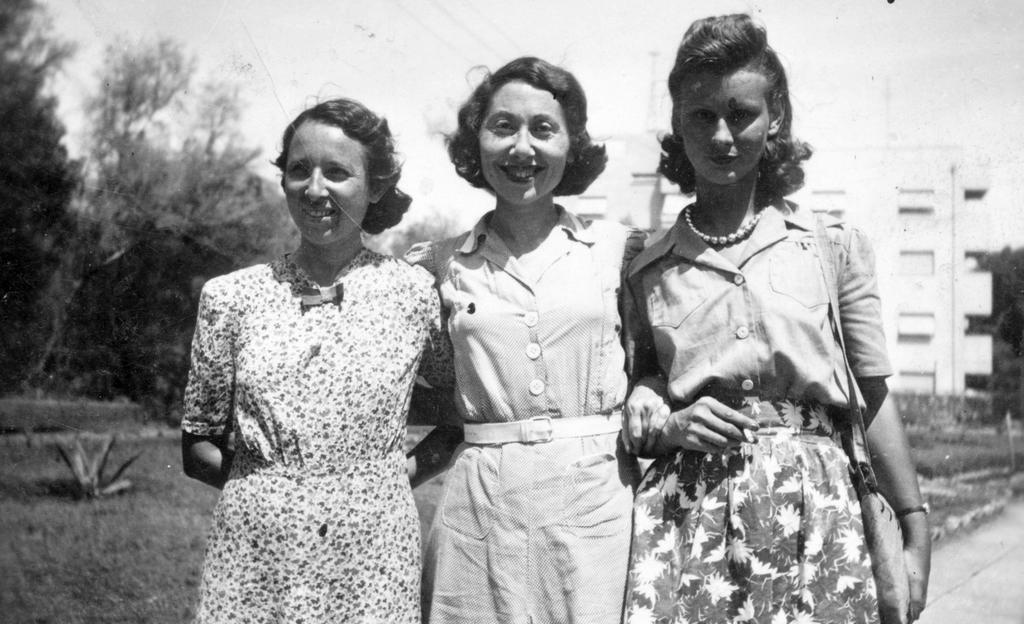How would you summarize this image in a sentence or two? This is a black and white image. There are three persons standing in the middle of this image. There are some trees on the left side of this image and there is a building on the right side of this image. There is a sky on the top of this image. 